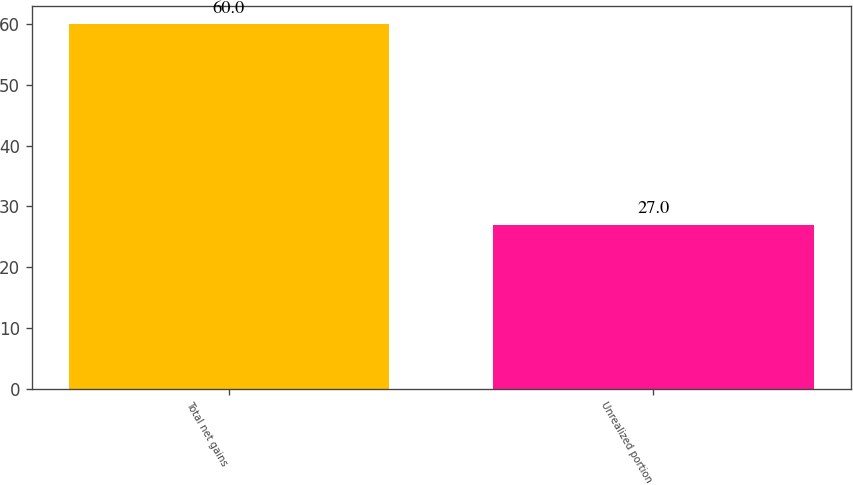Convert chart to OTSL. <chart><loc_0><loc_0><loc_500><loc_500><bar_chart><fcel>Total net gains<fcel>Unrealized portion<nl><fcel>60<fcel>27<nl></chart> 